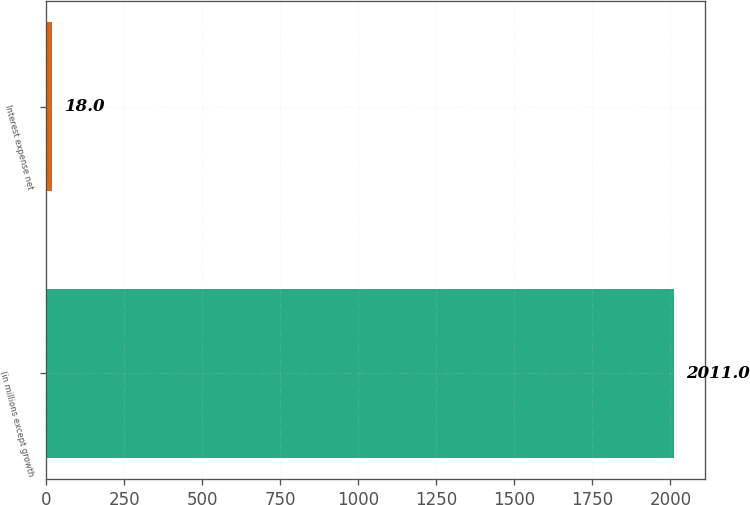Convert chart. <chart><loc_0><loc_0><loc_500><loc_500><bar_chart><fcel>(in millions except growth<fcel>Interest expense net<nl><fcel>2011<fcel>18<nl></chart> 